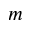Convert formula to latex. <formula><loc_0><loc_0><loc_500><loc_500>m</formula> 